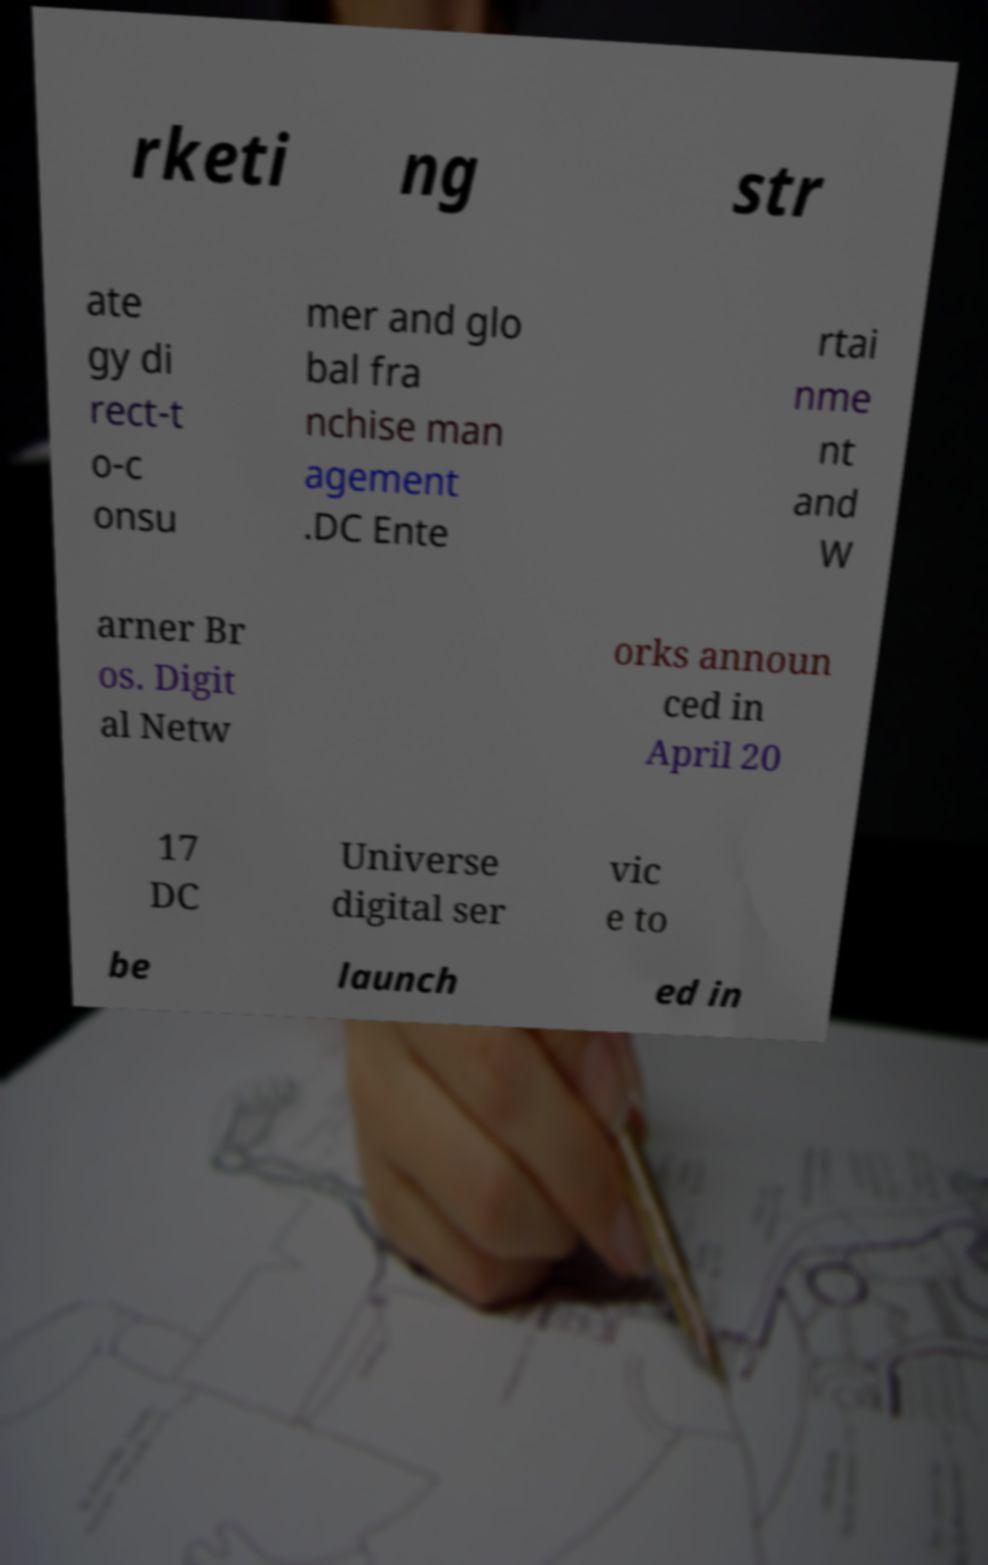Please read and relay the text visible in this image. What does it say? rketi ng str ate gy di rect-t o-c onsu mer and glo bal fra nchise man agement .DC Ente rtai nme nt and W arner Br os. Digit al Netw orks announ ced in April 20 17 DC Universe digital ser vic e to be launch ed in 